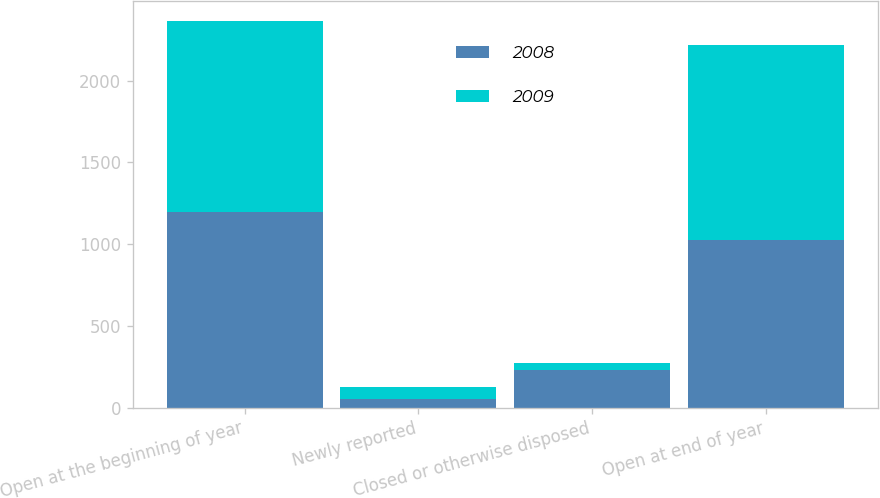<chart> <loc_0><loc_0><loc_500><loc_500><stacked_bar_chart><ecel><fcel>Open at the beginning of year<fcel>Newly reported<fcel>Closed or otherwise disposed<fcel>Open at end of year<nl><fcel>2008<fcel>1198<fcel>54<fcel>229<fcel>1023<nl><fcel>2009<fcel>1169<fcel>75<fcel>46<fcel>1198<nl></chart> 